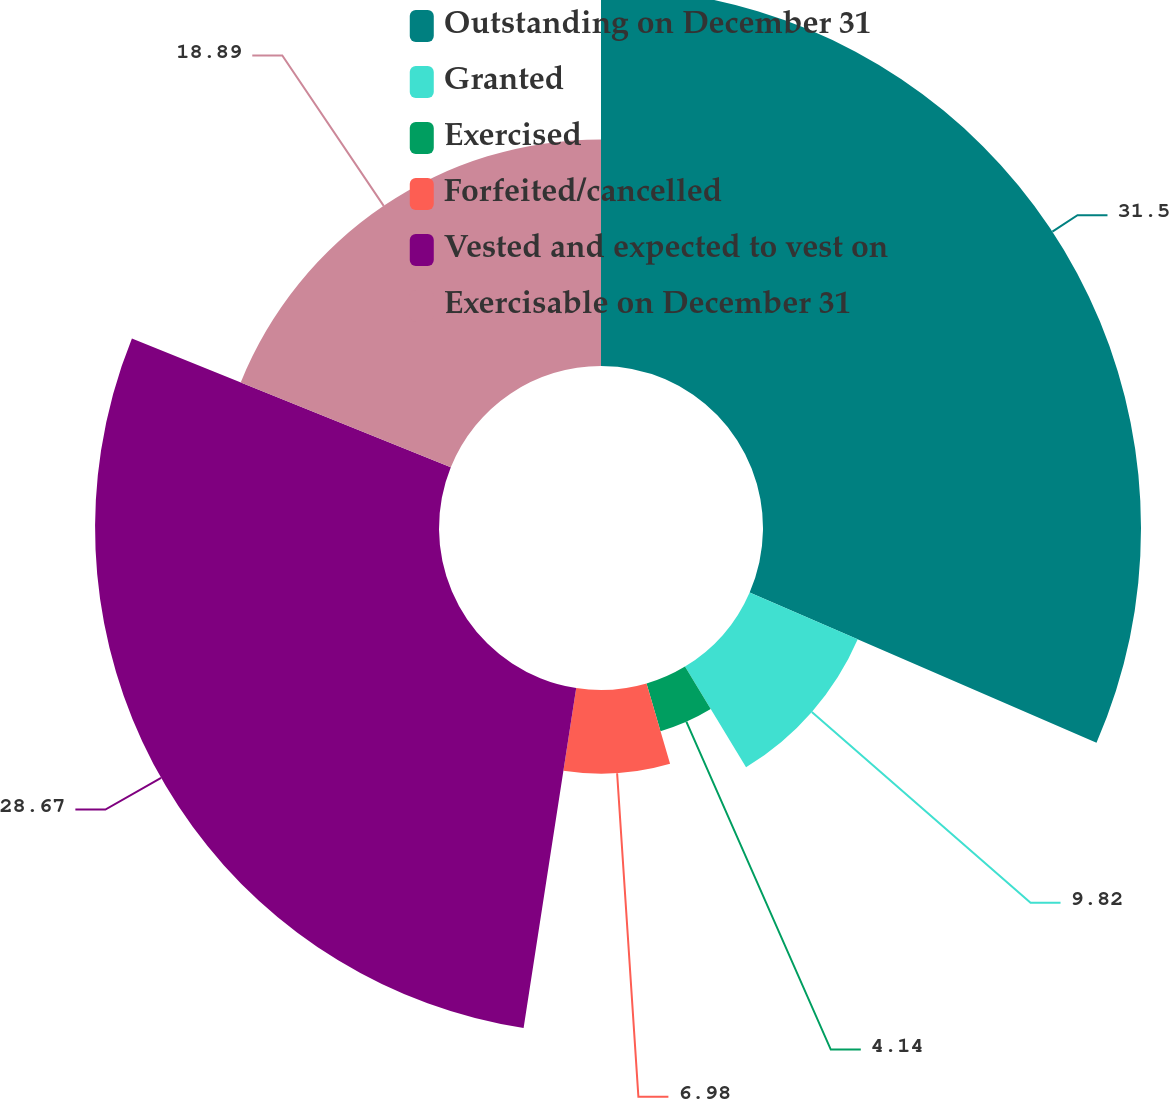Convert chart to OTSL. <chart><loc_0><loc_0><loc_500><loc_500><pie_chart><fcel>Outstanding on December 31<fcel>Granted<fcel>Exercised<fcel>Forfeited/cancelled<fcel>Vested and expected to vest on<fcel>Exercisable on December 31<nl><fcel>31.51%<fcel>9.82%<fcel>4.14%<fcel>6.98%<fcel>28.67%<fcel>18.89%<nl></chart> 